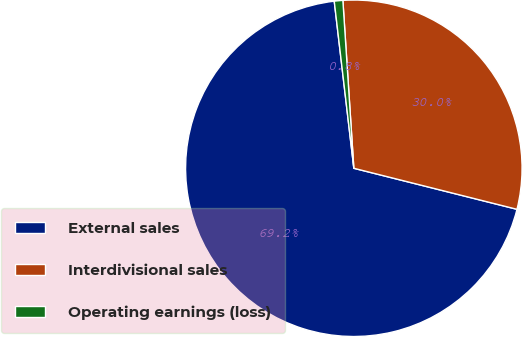Convert chart to OTSL. <chart><loc_0><loc_0><loc_500><loc_500><pie_chart><fcel>External sales<fcel>Interdivisional sales<fcel>Operating earnings (loss)<nl><fcel>69.22%<fcel>29.96%<fcel>0.82%<nl></chart> 